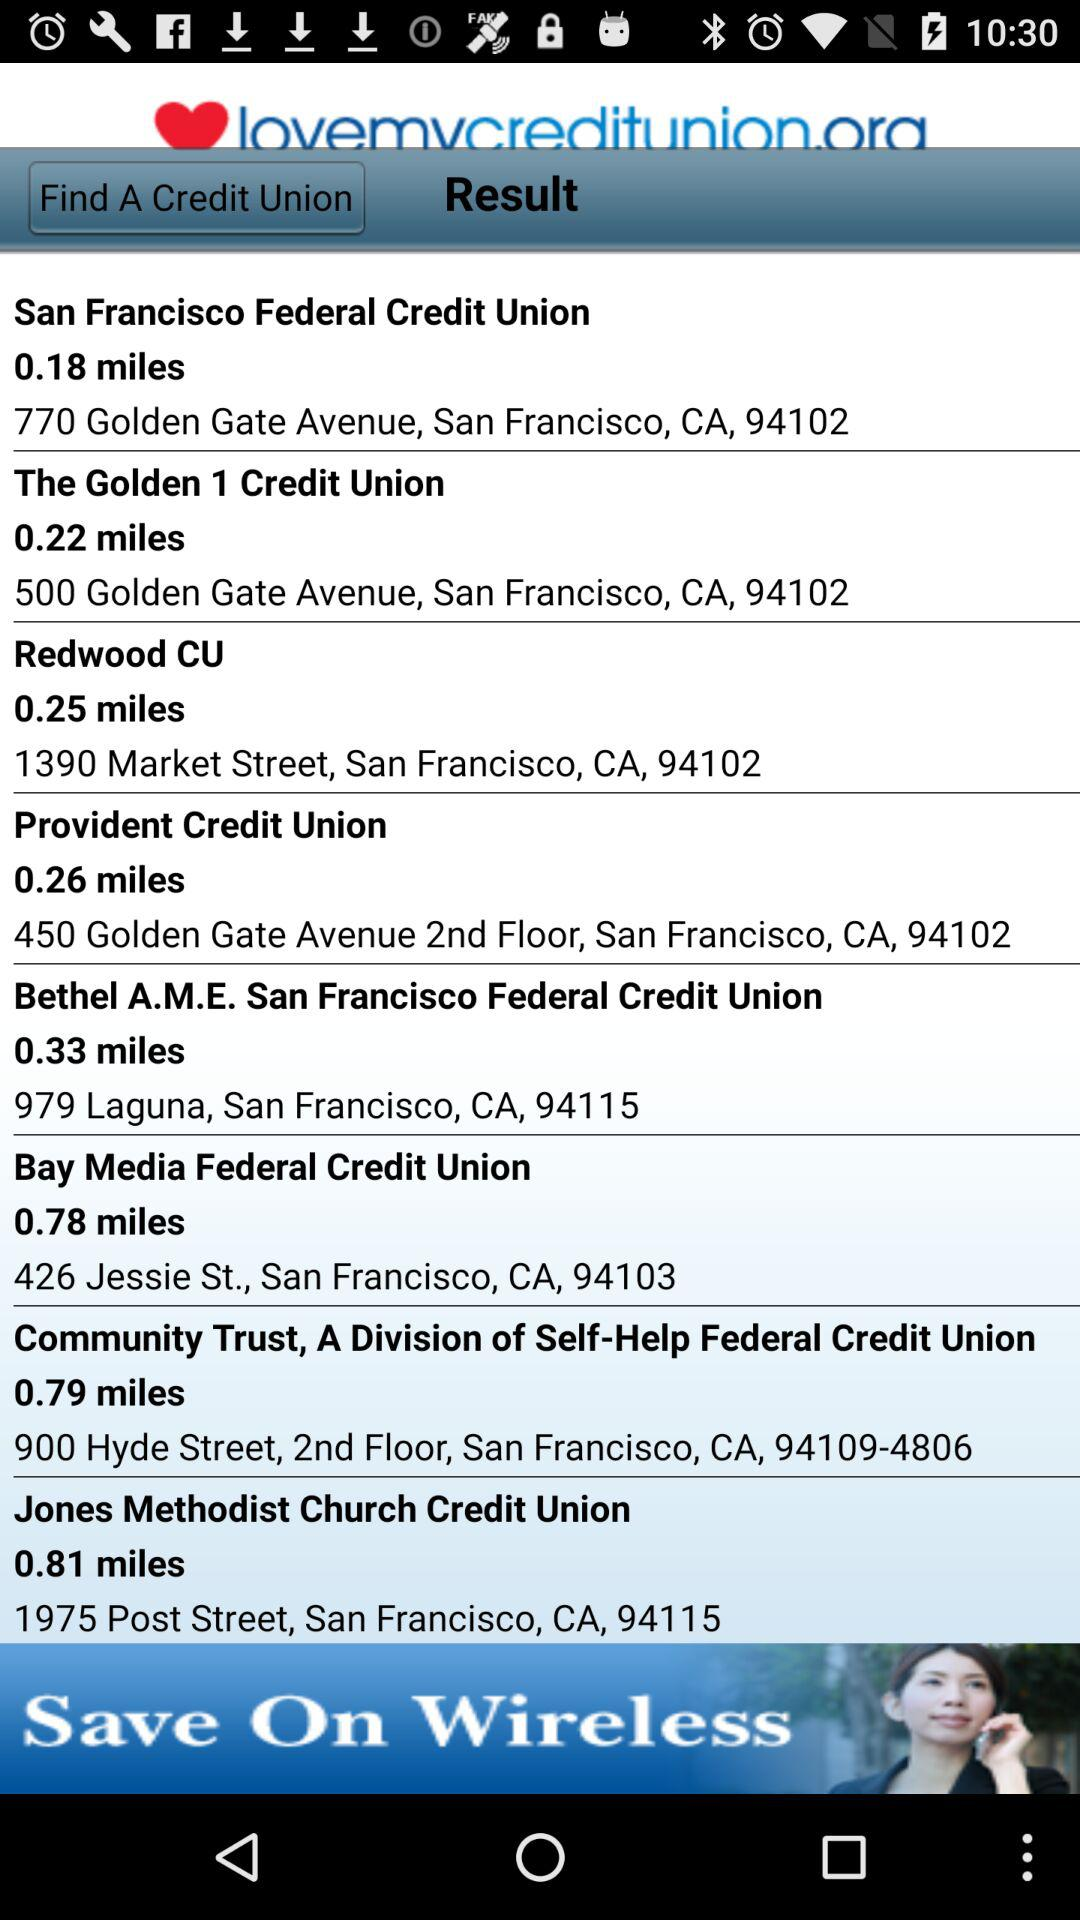Which credit union has the shortest distance to my location?
Answer the question using a single word or phrase. San Francisco Federal Credit Union 